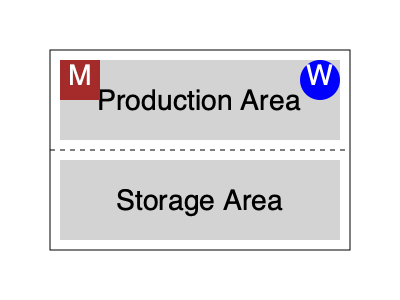Analyze the layout of this typical Victorian-era factory. What does the placement of the "M" and "W" areas suggest about the factory's organization and working conditions? 1. The diagram shows a simplified layout of a Victorian-era factory.
2. The factory is divided into two main sections: Production Area (top) and Storage Area (bottom).
3. In the top-left corner of the Production Area, there's a brown square labeled "M", likely representing the management or overseer's office.
4. In the top-right corner of the Production Area, there's a blue circle labeled "W", probably indicating the workers' area.
5. The placement of "M" suggests that management had a clear view of the entire production floor, allowing for constant supervision.
6. The "W" area's position implies that workers were confined to a specific space, possibly to maximize efficiency and control.
7. The separation between management and workers reflects the strict class divisions of Victorian society.
8. The layout emphasizes productivity and oversight, typical of the Industrial Revolution's focus on efficiency.
9. The absence of amenities for workers (e.g., rest areas) suggests poor working conditions, common in Victorian factories.
10. This design facilitated close monitoring and control of the workforce, a hallmark of Victorian industrial management practices.
Answer: Hierarchical control and worker supervision 